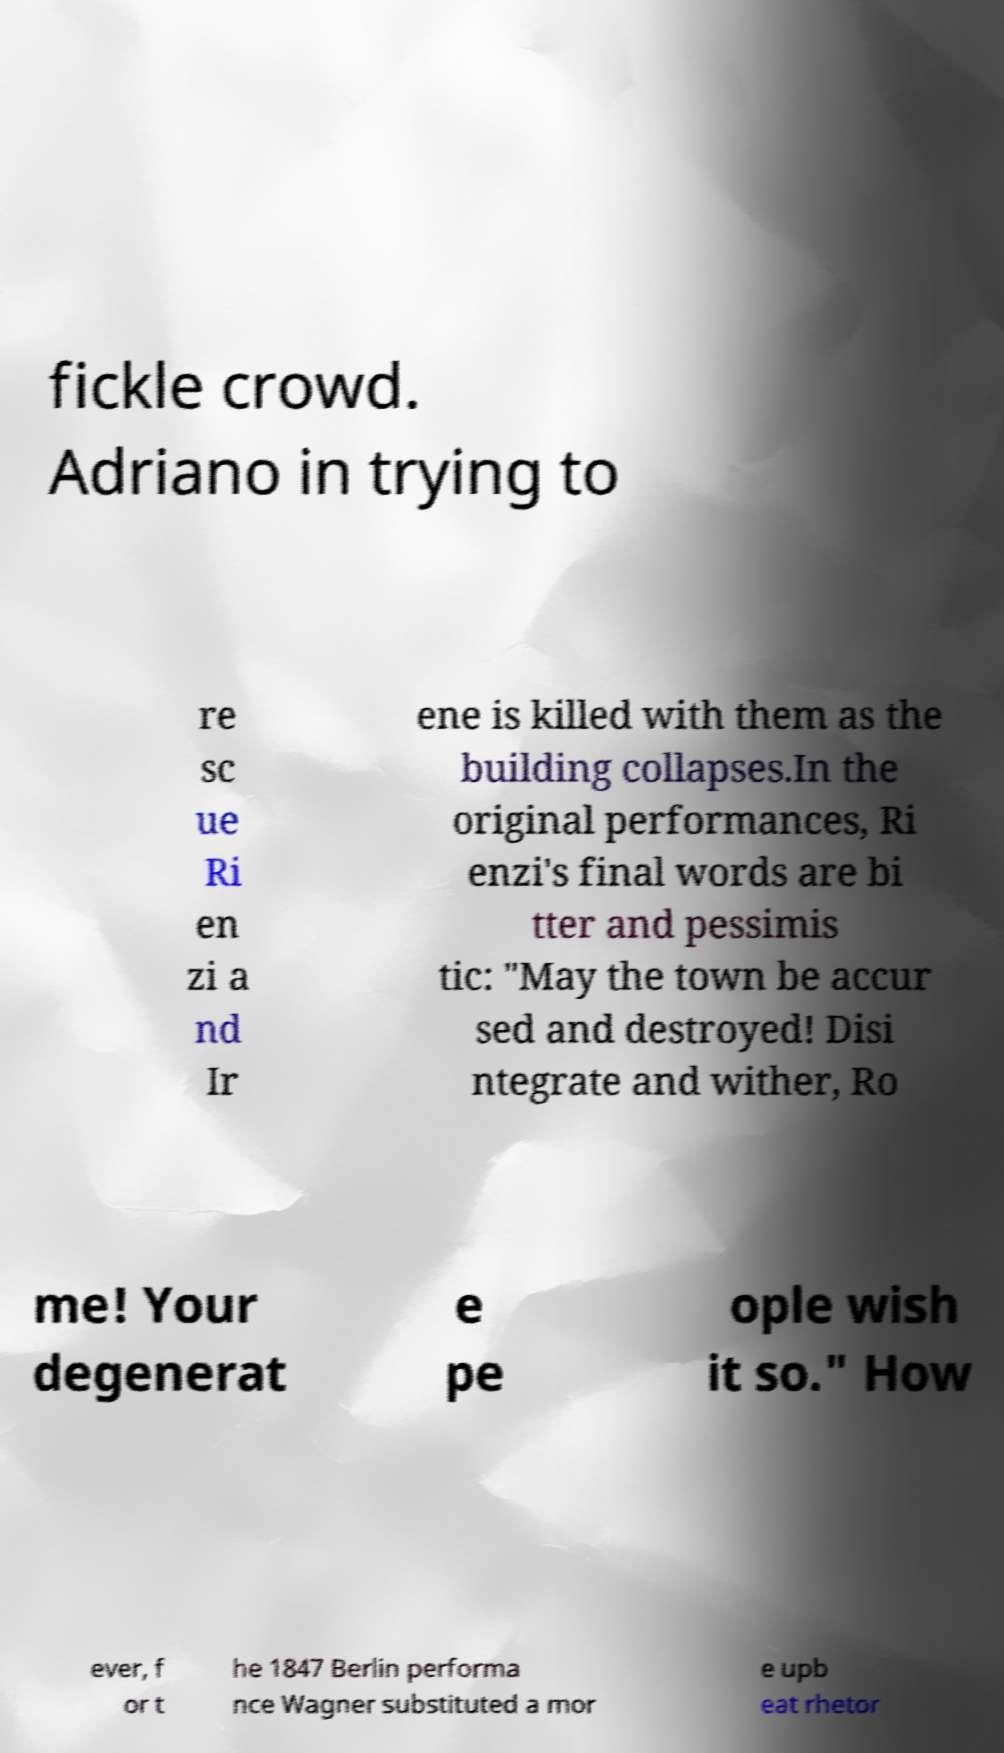There's text embedded in this image that I need extracted. Can you transcribe it verbatim? fickle crowd. Adriano in trying to re sc ue Ri en zi a nd Ir ene is killed with them as the building collapses.In the original performances, Ri enzi's final words are bi tter and pessimis tic: "May the town be accur sed and destroyed! Disi ntegrate and wither, Ro me! Your degenerat e pe ople wish it so." How ever, f or t he 1847 Berlin performa nce Wagner substituted a mor e upb eat rhetor 